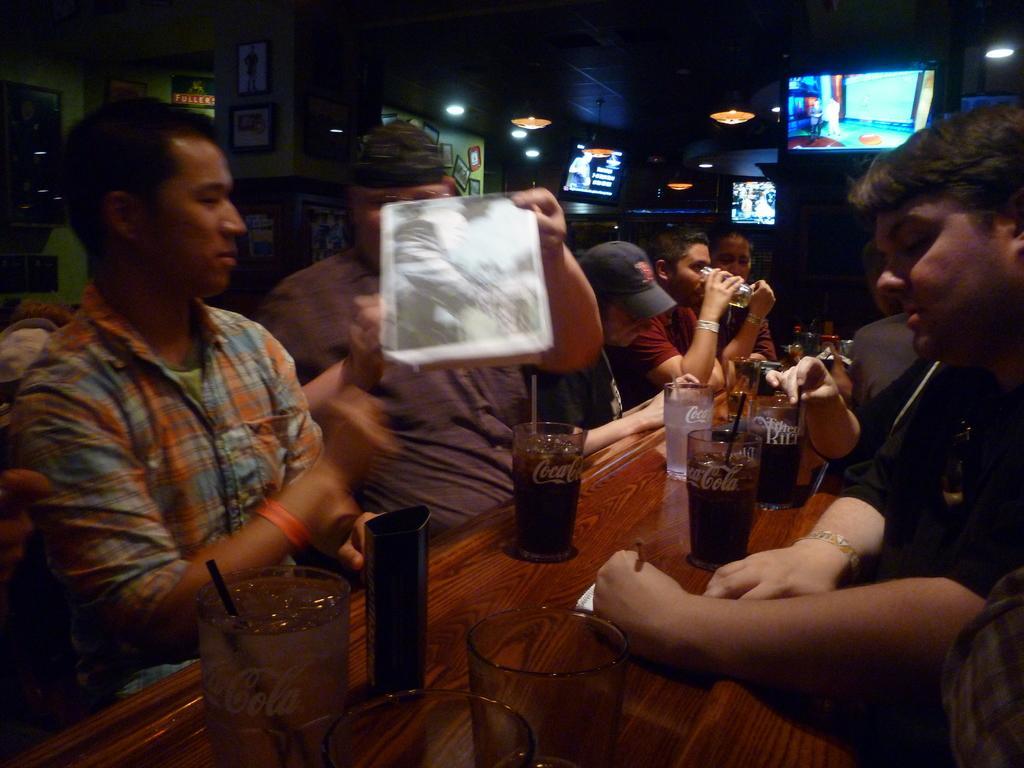In one or two sentences, can you explain what this image depicts? In this image, there are a few people. We can see the table with some objects like glasses. We can also see the wall with some objects like frames. We can see the roof and some lights. We can also see some screens. 